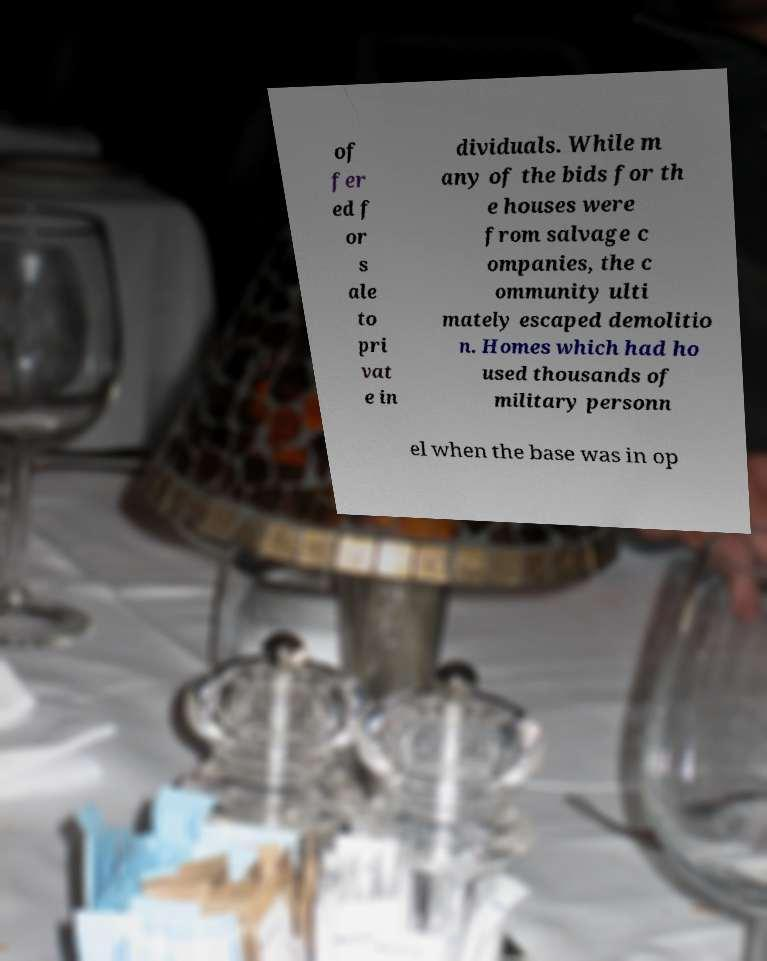Could you assist in decoding the text presented in this image and type it out clearly? of fer ed f or s ale to pri vat e in dividuals. While m any of the bids for th e houses were from salvage c ompanies, the c ommunity ulti mately escaped demolitio n. Homes which had ho used thousands of military personn el when the base was in op 